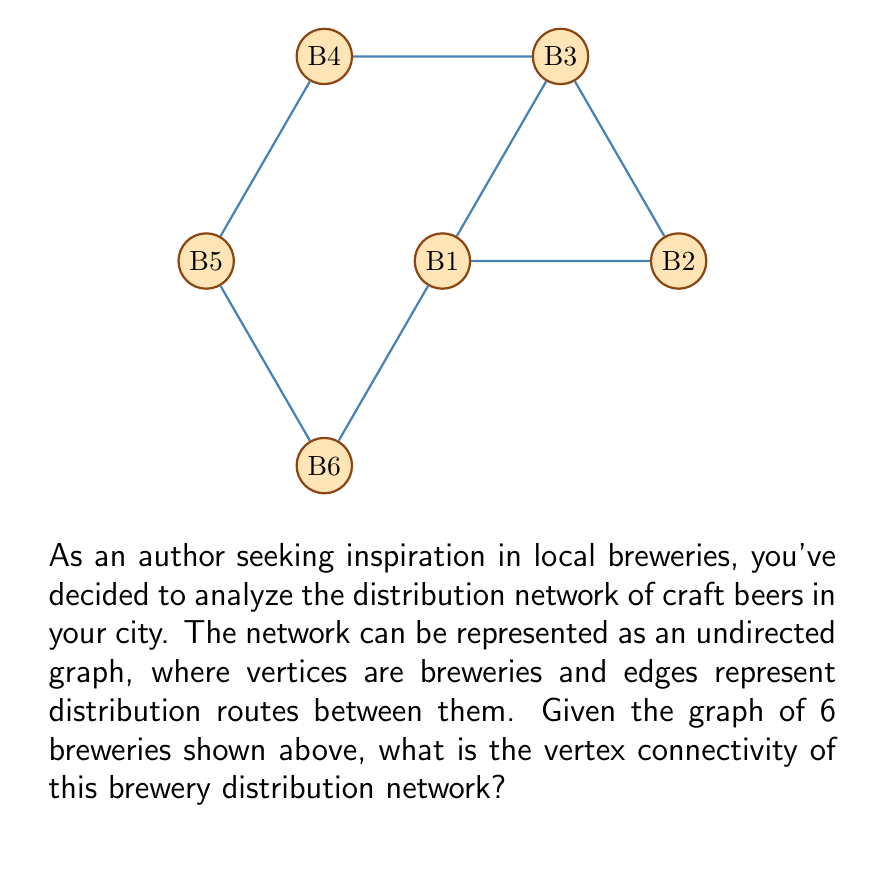Solve this math problem. To find the vertex connectivity of this graph, we need to determine the minimum number of vertices that need to be removed to disconnect the graph. Let's approach this step-by-step:

1) First, recall that the vertex connectivity $\kappa(G)$ is the minimum number of vertices whose removal results in a disconnected or trivial graph.

2) Observe the graph structure:
   - It forms a cycle of 6 vertices (B1-B6-B5-B4-B3-B2-B1)
   - There's an additional edge connecting B1 and B3

3) Let's consider removing vertices:
   - Removing any single vertex doesn't disconnect the graph
   - Removing B2 and B5 disconnects the graph into two components: {B1, B3} and {B4, B6}

4) We need to prove that removing only one vertex is insufficient:
   - If we remove B1, the remaining vertices are still connected through the path B2-B3-B4-B5-B6
   - The same is true for removing any other single vertex

5) Therefore, the minimum number of vertices that need to be removed to disconnect the graph is 2.

Thus, the vertex connectivity $\kappa(G) = 2$.
Answer: $\kappa(G) = 2$ 